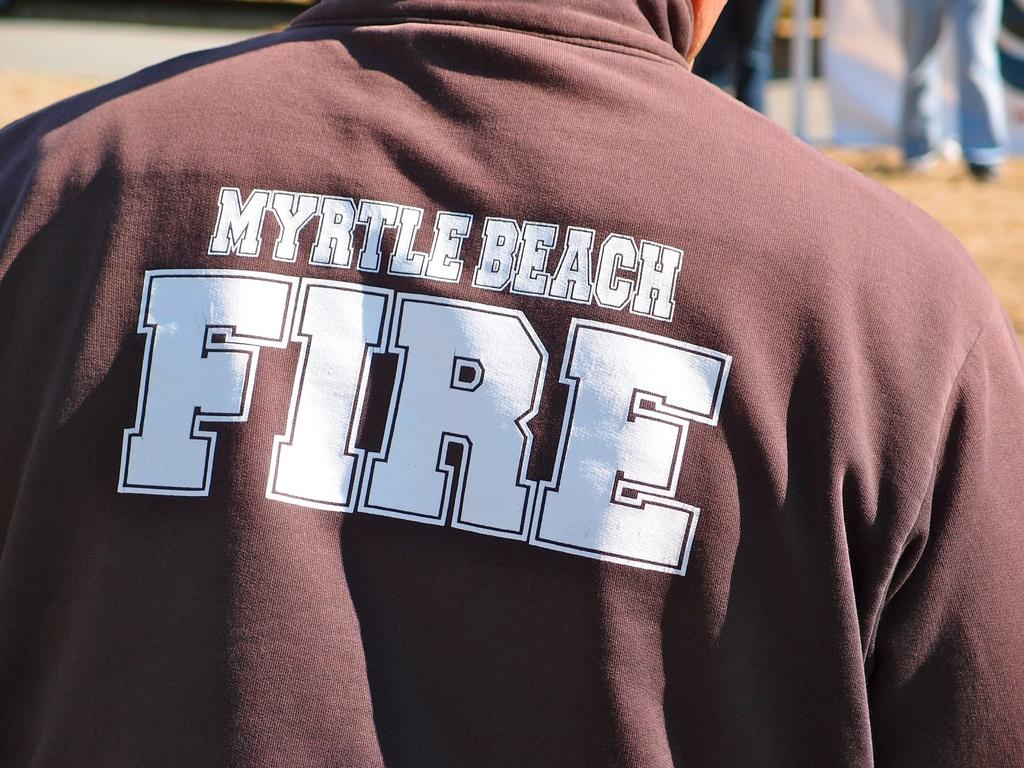<image>
Write a terse but informative summary of the picture. A person is outdoors wearing a Myrtle Beach Fire t-shirt. 